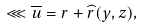Convert formula to latex. <formula><loc_0><loc_0><loc_500><loc_500>\lll \overline { u } = r + \widehat { r } ( y , z ) ,</formula> 